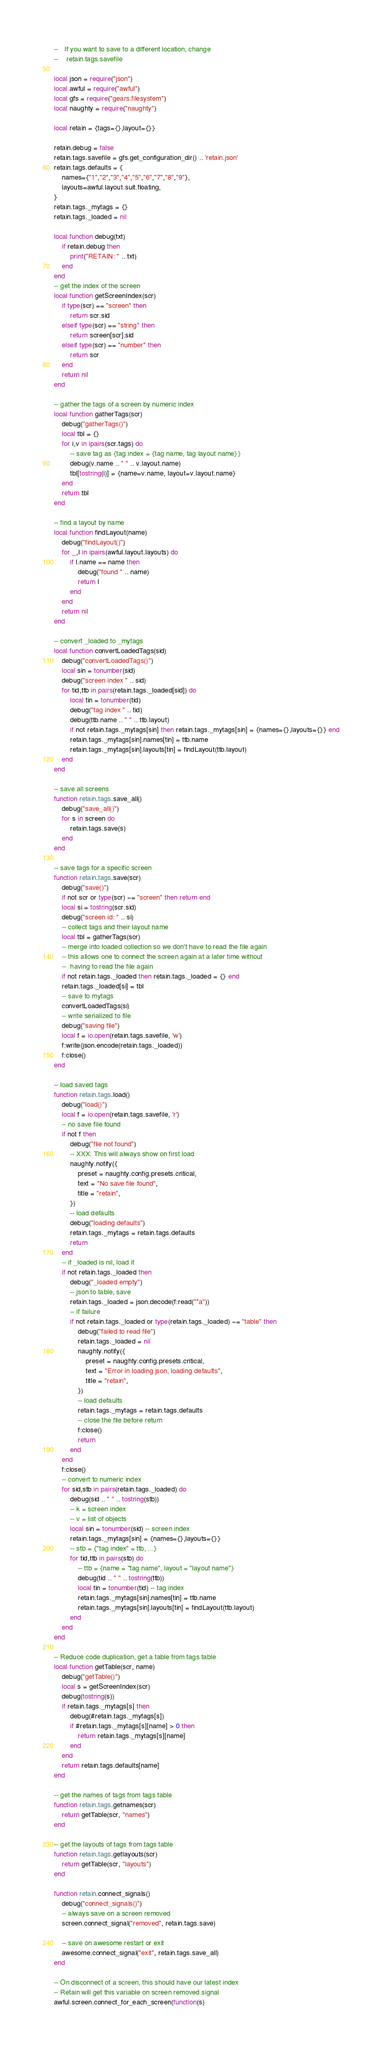Convert code to text. <code><loc_0><loc_0><loc_500><loc_500><_Lua_>--   If you want to save to a different location, change
--    retain.tags.savefile

local json = require("json")
local awful = require("awful")
local gfs = require("gears.filesystem")
local naughty = require("naughty")

local retain = {tags={},layout={}}

retain.debug = false
retain.tags.savefile = gfs.get_configuration_dir() .. 'retain.json'
retain.tags.defaults = {
	names={"1","2","3","4","5","6","7","8","9"},
	layouts=awful.layout.suit.floating,
}
retain.tags._mytags = {}
retain.tags._loaded = nil

local function debug(txt)
	if retain.debug then
		print("RETAIN: " .. txt)
	end
end
-- get the index of the screen
local function getScreenIndex(scr)
	if type(scr) == "screen" then
		return scr.sid
	elseif type(scr) == "string" then
		return screen[scr].sid
	elseif type(scr) == "number" then
		return scr
	end
	return nil
end

-- gather the tags of a screen by numeric index
local function gatherTags(scr)
	debug("gatherTags()")
	local tbl = {}
	for i,v in ipairs(scr.tags) do
		-- save tag as {tag index = {tag name, tag layout name}}
		debug(v.name .. " " .. v.layout.name)
		tbl[tostring(i)] = {name=v.name, layout=v.layout.name}
	end
	return tbl
end

-- find a layout by name
local function findLayout(name)
	debug("findLayout()")
	for _,l in ipairs(awful.layout.layouts) do
		if l.name == name then
			debug("found " .. name)
			return l
		end
	end
	return nil
end

-- convert _loaded to _mytags
local function convertLoadedTags(sid)
	debug("convertLoadedTags()")
	local sin = tonumber(sid)
	debug("screen index " .. sid)
	for tid,ttb in pairs(retain.tags._loaded[sid]) do
		local tin = tonumber(tid)
		debug("tag index " .. tid)
		debug(ttb.name .. " " .. ttb.layout)
		if not retain.tags._mytags[sin] then retain.tags._mytags[sin] = {names={},layouts={}} end
		retain.tags._mytags[sin].names[tin] = ttb.name
		retain.tags._mytags[sin].layouts[tin] = findLayout(ttb.layout)
	end
end

-- save all screens
function retain.tags.save_all()
	debug("save_all()")
	for s in screen do
		retain.tags.save(s)
	end
end

-- save tags for a specific screen
function retain.tags.save(scr)
	debug("save()")
	if not scr or type(scr) ~= "screen" then return end
	local si = tostring(scr.sid)
	debug("screen id: " .. si)
	-- collect tags and their layout name
	local tbl = gatherTags(scr)
	-- merge into loaded collection so we don't have to read the file again
	-- this allows one to connect the screen again at a later time without
	--  having to read the file again
	if not retain.tags._loaded then retain.tags._loaded = {} end
	retain.tags._loaded[si] = tbl
	-- save to mytags
	convertLoadedTags(si)
	-- write serialized to file
	debug("saving file")
	local f = io.open(retain.tags.savefile, 'w')
	f:write(json.encode(retain.tags._loaded))
	f:close()
end

-- load saved tags
function retain.tags.load()
	debug("load()")
	local f = io.open(retain.tags.savefile, 'r')
	-- no save file found
	if not f then
		debug("file not found")
		-- XXX: This will always show on first load
		naughty.notify({
			preset = naughty.config.presets.critical,
			text = "No save file found",
			title = "retain",
		})
		-- load defaults
		debug("loading defaults")
		retain.tags._mytags = retain.tags.defaults
		return
	end
	-- if _loaded is nil, load it
	if not retain.tags._loaded then
		debug("_loaded empty")
		-- json to table, save
		retain.tags._loaded = json.decode(f:read("*a"))
		-- if failure
		if not retain.tags._loaded or type(retain.tags._loaded) ~= "table" then
			debug("failed to read file")
			retain.tags._loaded = nil
			naughty.notify({
				preset = naughty.config.presets.critical,
				text = "Error in loading json, loading defaults",
				title = "retain",
			})
			-- load defaults
			retain.tags._mytags = retain.tags.defaults
			-- close the file before return
			f:close()
			return
		end
	end
	f:close()
	-- convert to numeric index
	for sid,stb in pairs(retain.tags._loaded) do
		debug(sid .. " " .. tostring(stb))
		-- k = screen index
		-- v = list of objects
		local sin = tonumber(sid) -- screen index
		retain.tags._mytags[sin] = {names={},layouts={}}
		-- stb = {"tag index" = ttb, ...}
		for tid,ttb in pairs(stb) do
			-- ttb = {name = "tag name", layout = "layout name"}
			debug(tid .. " " .. tostring(ttb))
			local tin = tonumber(tid) -- tag index
			retain.tags._mytags[sin].names[tin] = ttb.name
			retain.tags._mytags[sin].layouts[tin] = findLayout(ttb.layout)
		end
	end
end

-- Reduce code duplication, get a table from tags table
local function getTable(scr, name)
	debug("getTable()")
	local s = getScreenIndex(scr)
	debug(tostring(s))
	if retain.tags._mytags[s] then
		debug(#retain.tags._mytags[s])
		if #retain.tags._mytags[s][name] > 0 then
			return retain.tags._mytags[s][name]
		end
	end
	return retain.tags.defaults[name]
end

-- get the names of tags from tags table
function retain.tags.getnames(scr)
	return getTable(scr, "names")
end

-- get the layouts of tags from tags table
function retain.tags.getlayouts(scr)
	return getTable(scr, "layouts")
end

function retain.connect_signals()
	debug("connect_signals()")
	-- always save on a screen removed
	screen.connect_signal("removed", retain.tags.save)

	-- save on awesome restart or exit
	awesome.connect_signal("exit", retain.tags.save_all)
end

-- On disconnect of a screen, this should have our latest index
-- Retain will get this variable on screen removed signal
awful.screen.connect_for_each_screen(function(s)</code> 